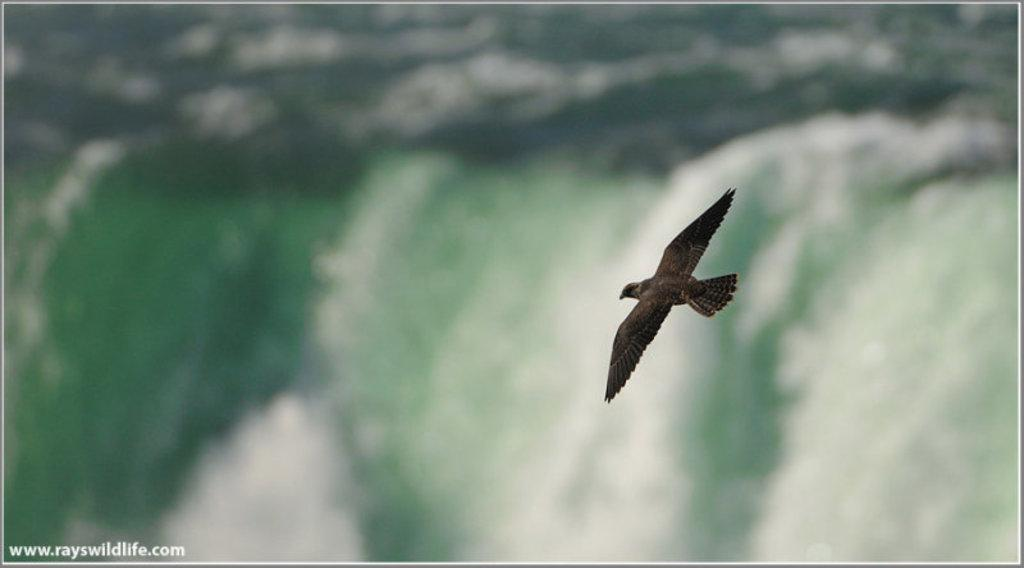What is present in the image? There is a bird in the image. What is the bird doing in the image? The bird is flying in the air. What type of pollution can be seen in the image? There is no pollution present in the image; it features a bird flying in the air. What is the bird using to clear its throat in the image? There is no indication in the image that the bird is clearing its throat, and birds do not have the ability to use external objects for that purpose. 